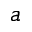<formula> <loc_0><loc_0><loc_500><loc_500>a</formula> 